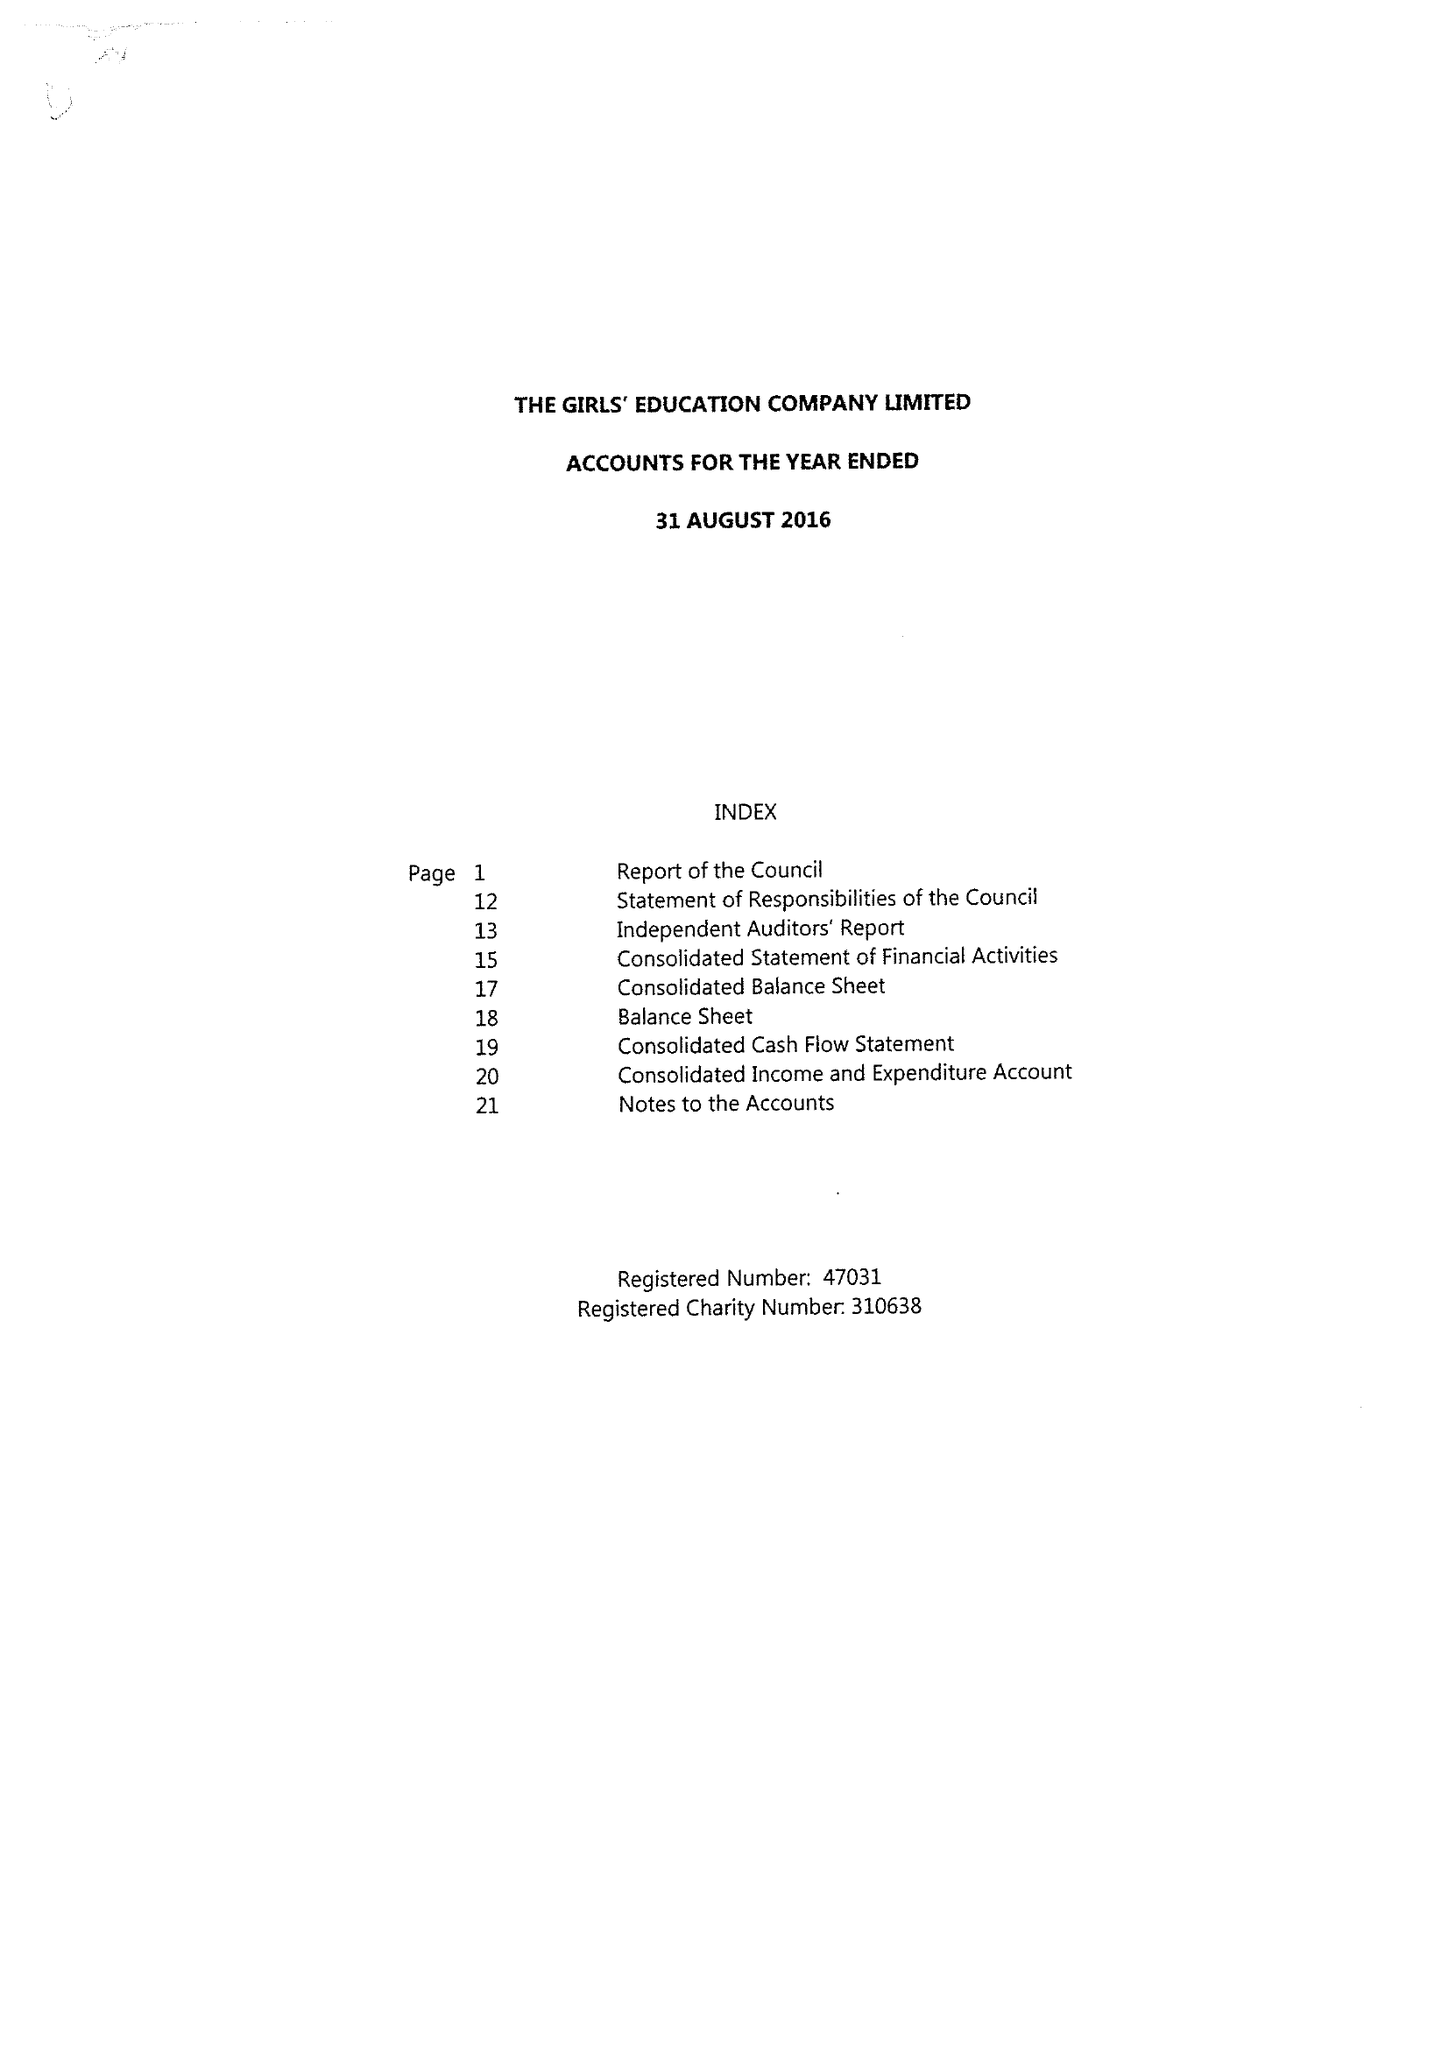What is the value for the report_date?
Answer the question using a single word or phrase. 2016-08-31 